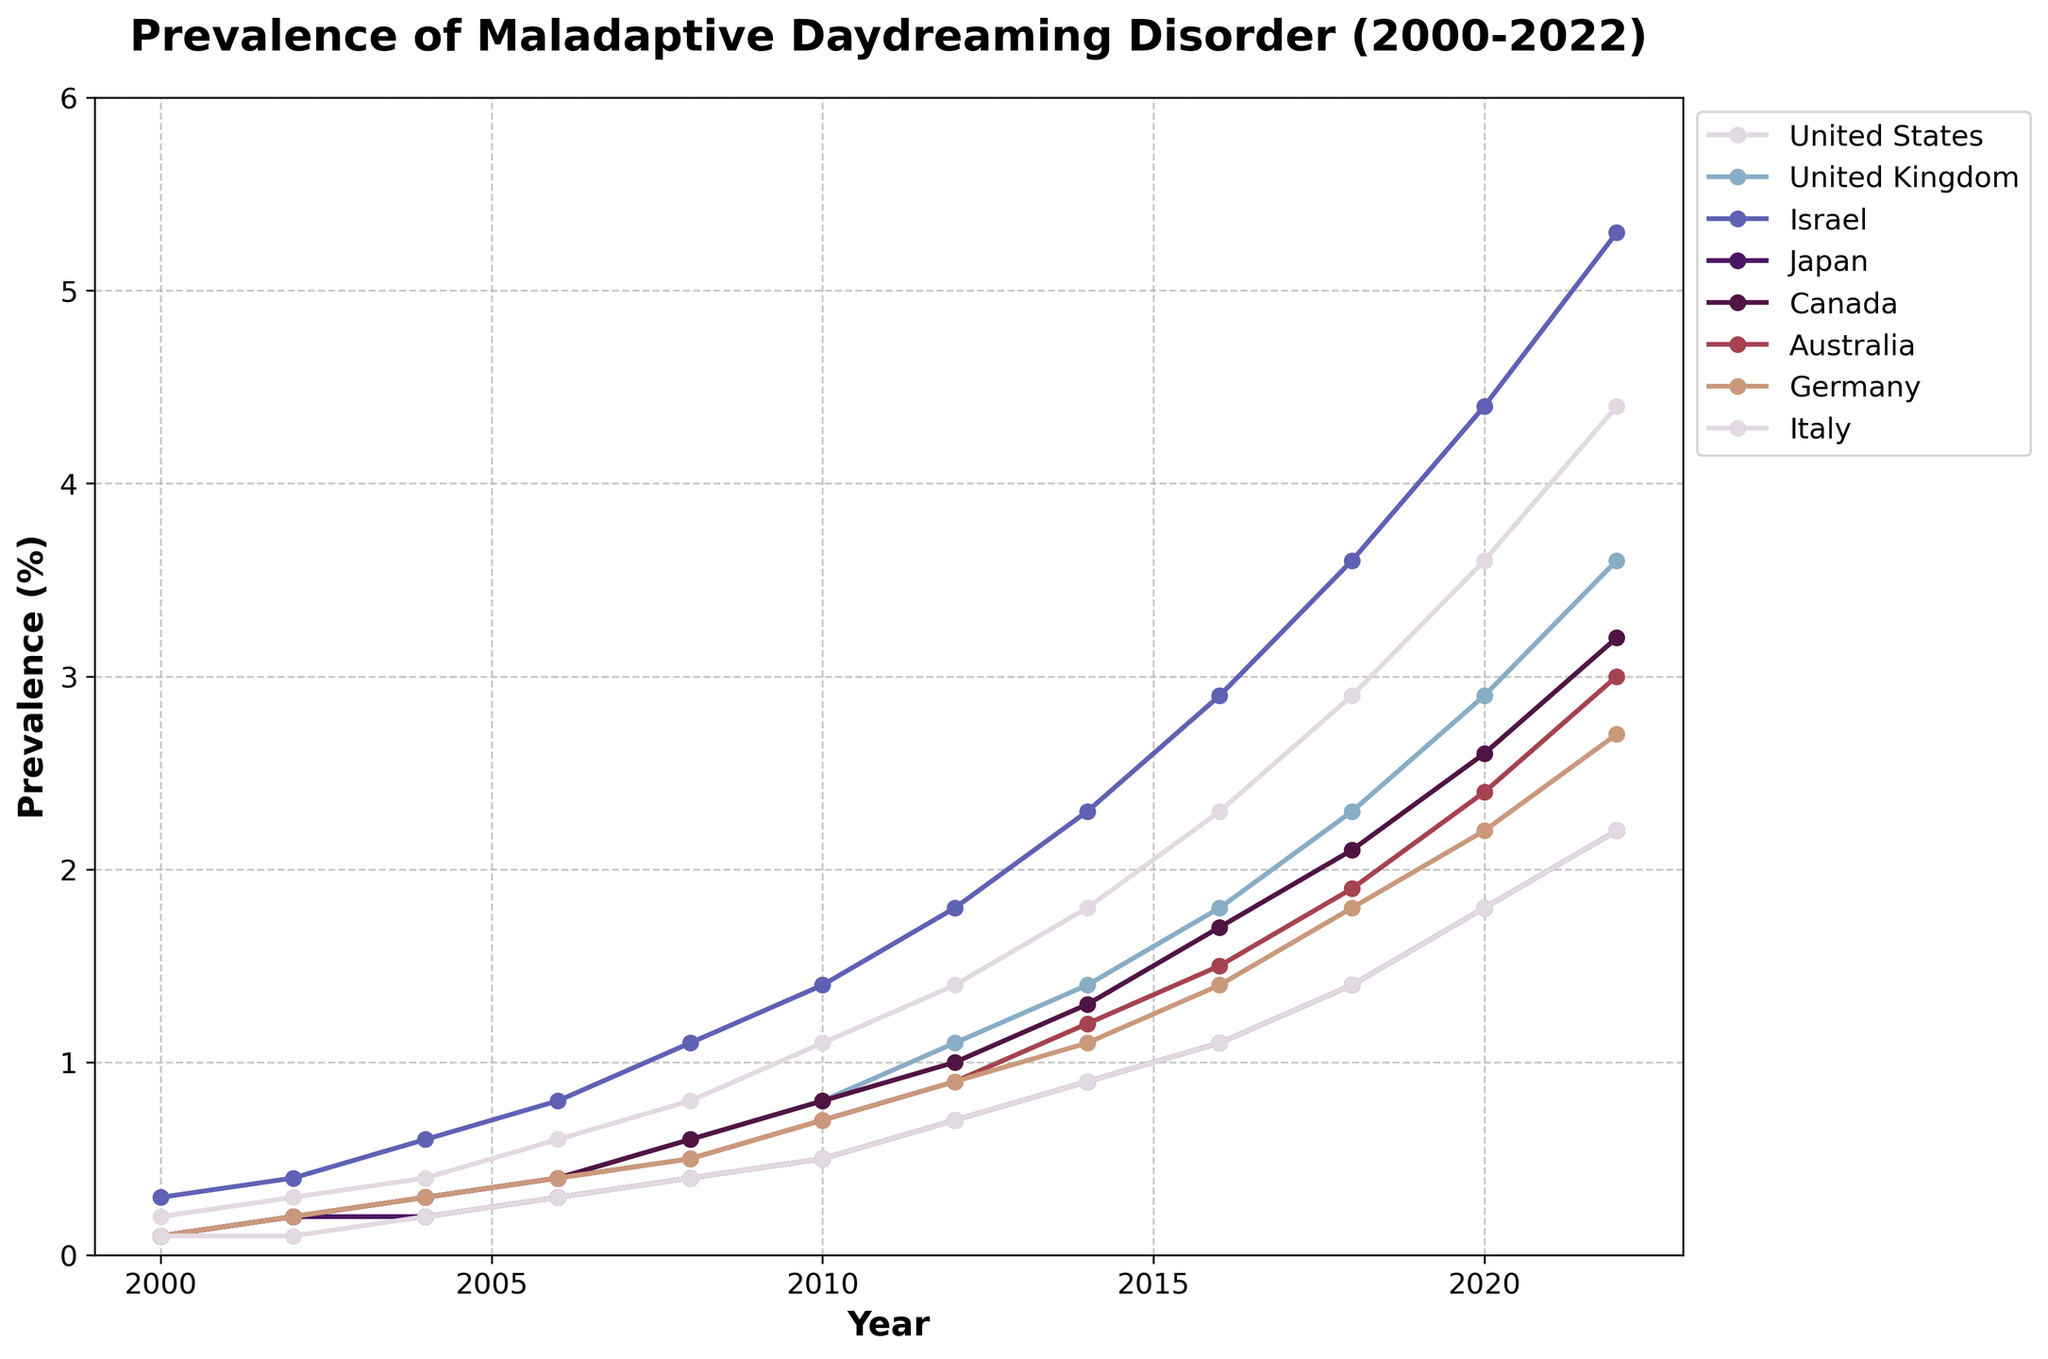What is the prevalence of maladaptive daydreaming disorder in Israel in 2020? To answer this question, locate the data point for Israel along the y-axis at the year 2020 on the x-axis.
Answer: 4.4% Which country had the lowest prevalence of maladaptive daydreaming disorder in 2008? Look at the data points across all countries for the year 2008 and find the smallest value along the y-axis.
Answer: Italy How did the prevalence of maladaptive daydreaming disorder in the United Kingdom in 2006 compare to that in Japan in the same year? Identify the data points for both the United Kingdom and Japan for the year 2006, then compare their y-axis values.
Answer: Higher in the United Kingdom What is the overall trend in the prevalence of maladaptive daydreaming disorder in the United States from 2000 to 2022? Observe the line corresponding to the United States from 2000 to 2022 and note whether it generally rises, falls, or remains constant.
Answer: Increasing By how much did the prevalence of maladaptive daydreaming disorder increase in Canada from 2012 to 2016? Find the y-axis values for Canada in 2012 and 2016, then subtract the 2012 value from the 2016 value to find the difference.
Answer: 0.7% Which country had the highest prevalence of maladaptive daydreaming disorder in 2022? Locate all the data points for the year 2022 and find the country with the highest y-axis value.
Answer: Israel How did Australia's prevalence of maladaptive daydreaming disorder in 2000 compare to its prevalence in 2022? Find the y-axis values for Australia in both 2000 and 2022, then compare those values.
Answer: Higher in 2022 What is the average prevalence of maladaptive daydreaming disorder in Germany from 2000 to 2022? Sum the prevalence values for Germany from 2000 to 2022 and divide by the number of data points.
Answer: 1.45% If you were to plot a trend line for Japan from 2000 to 2022, would it be upward, downward, or flat? Look at how the data for Japan changes from 2000 to 2022 and determine the general direction of the trend.
Answer: Upward Which two countries showed the most similar prevalence rates in 2010? Compare the data points for all countries in the year 2010 and identify which two countries have the closest y-axis values.
Answer: Germany and Australia 